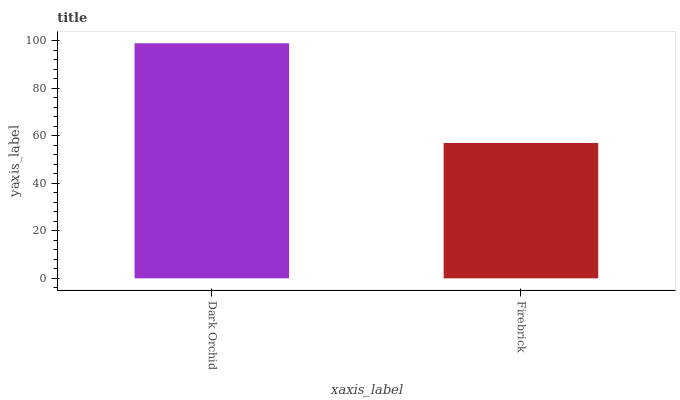Is Firebrick the minimum?
Answer yes or no. Yes. Is Dark Orchid the maximum?
Answer yes or no. Yes. Is Firebrick the maximum?
Answer yes or no. No. Is Dark Orchid greater than Firebrick?
Answer yes or no. Yes. Is Firebrick less than Dark Orchid?
Answer yes or no. Yes. Is Firebrick greater than Dark Orchid?
Answer yes or no. No. Is Dark Orchid less than Firebrick?
Answer yes or no. No. Is Dark Orchid the high median?
Answer yes or no. Yes. Is Firebrick the low median?
Answer yes or no. Yes. Is Firebrick the high median?
Answer yes or no. No. Is Dark Orchid the low median?
Answer yes or no. No. 